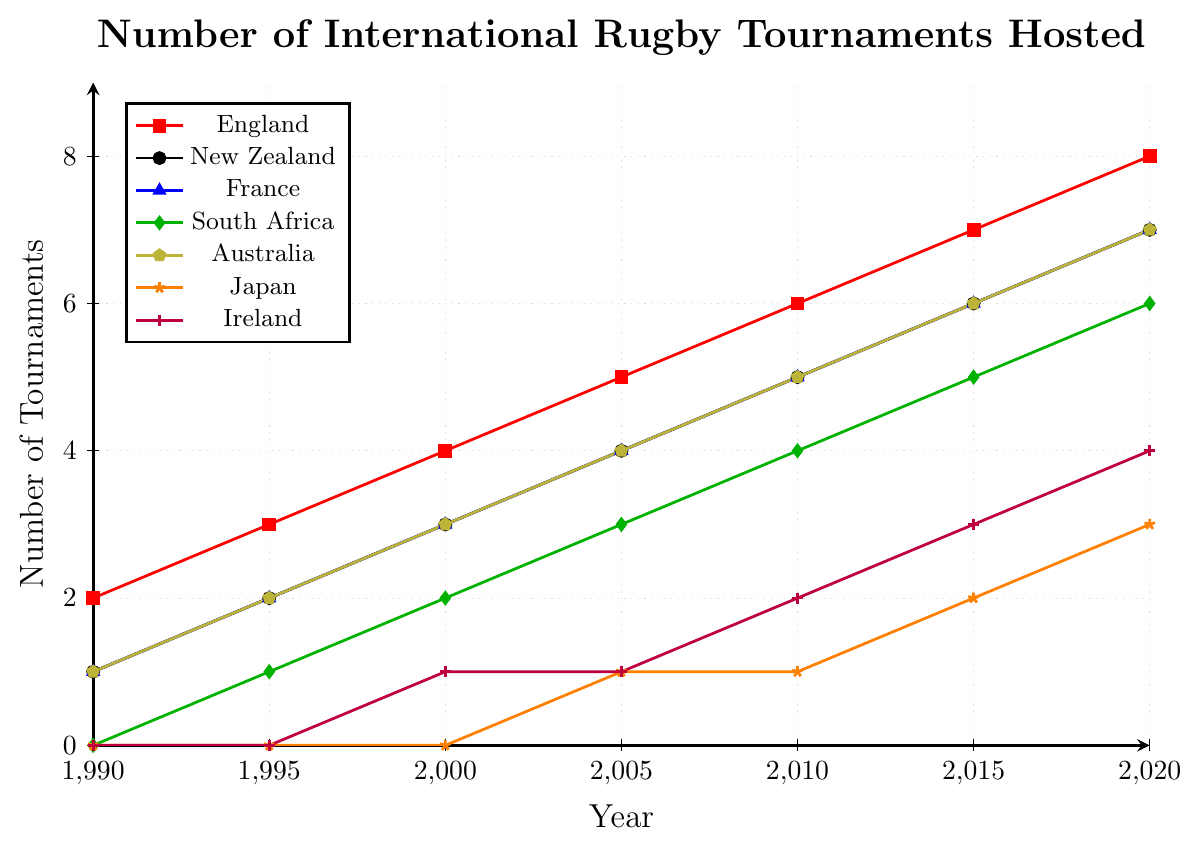What's the trend in the number of tournaments hosted by England from 1990 to 2020? To determine the trend, observe the red line representing England. The line is steadily increasing from 2 tournaments in 1990 to 8 tournaments in 2020. This indicates a clear upward trend.
Answer: Upward trend Which country hosted the least number of tournaments by the year 2000? To find the country with the least tournaments by 2000, compare the y-values for all countries at the year 2000. South Africa and Japan both hosted 2 tournaments each by 2000, the least among all.
Answer: South Africa and Japan Between 1995 and 2015, which country saw the largest increase in the number of tournaments hosted? To find the largest increase, calculate the difference in the number of tournaments from 1995 to 2015 for each country:  
- England: 7 - 3 = 4 
- New Zealand: 6 - 2 = 4  
- France: 6 - 2 = 4  
- South Africa: 5 - 1 = 4  
- Australia: 6 - 2 = 4 
- Japan: 2 - 0 = 2  
- Ireland: 3 - 0 = 3  
All countries except Japan and Ireland show a similar increase of 4.
Answer: England, New Zealand, France, South Africa, Australia In which year did Japan host its first international rugby tournament? Following the orange line, Japan's count goes from 0 to 1 between 2000 and 2005. Therefore, the first hosted tournament by Japan was in 2005.
Answer: 2005 What is the average number of tournaments hosted by Australia over the entire period? To find the average, we sum the number of tournaments hosted by Australia across all years and divide by the number of data points:
(1+2+3+4+5+6+7) / 7 = 28 / 7 = 4
Answer: 4 Which countries had identical numbers of tournaments hosted in the year 1990? By observing the y-values for each country at 1990, New Zealand, France, and Australia all have hosted 1 tournament each.
Answer: New Zealand, France, Australia How many more tournaments had England hosted compared to Japan by 2020? Compare the points for 2020: England has 8; Japan has 3. The difference is 8 - 3 = 5.
Answer: 5 What is the total number of tournaments hosted by France and Ireland in 2010? Add the totals for 2010: France (5) + Ireland (2) = 7.
Answer: 7 Identify the country represented by the green line and describe its trend. Examine the line's attributes: green with diamonds. The trend starts at 0 in 1990 and reaches 6 by 2020, indicating South Africa, showing a steady increase.
Answer: South Africa, upward trend 